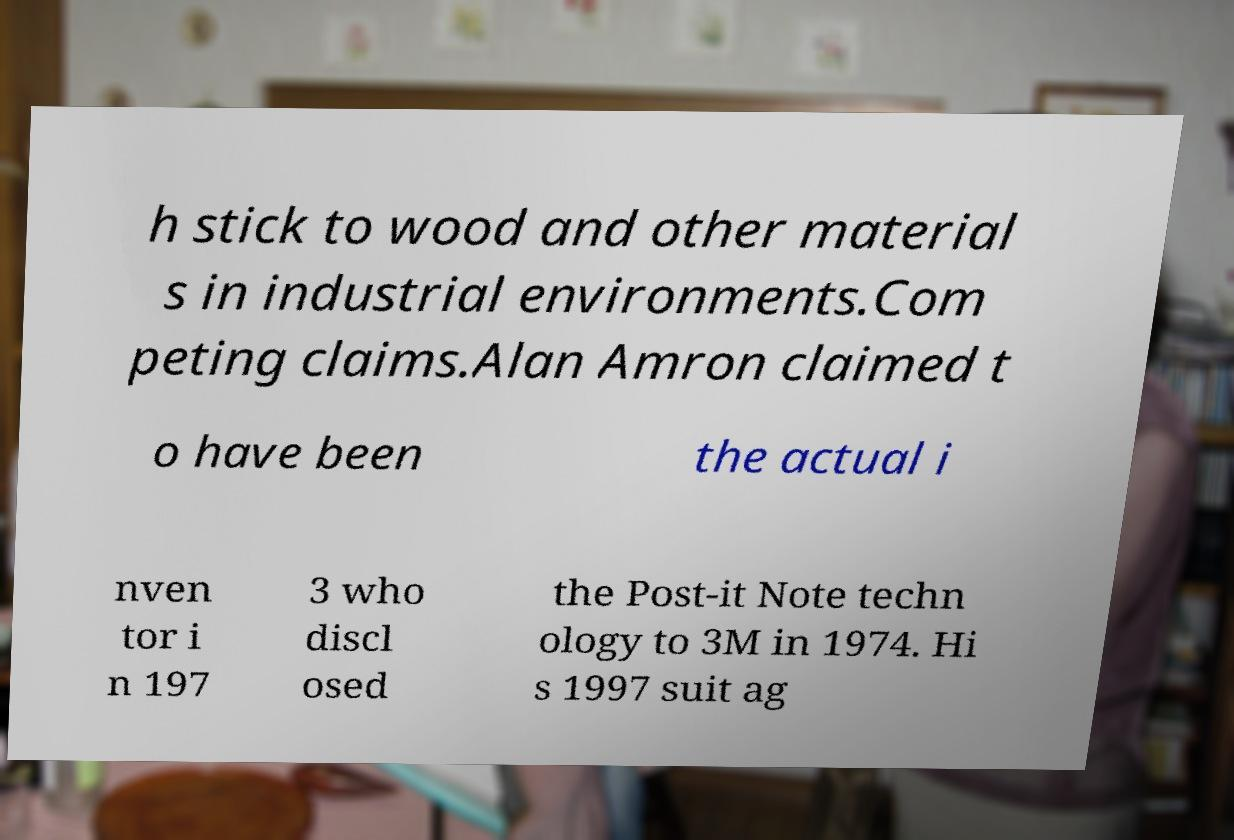Can you read and provide the text displayed in the image?This photo seems to have some interesting text. Can you extract and type it out for me? h stick to wood and other material s in industrial environments.Com peting claims.Alan Amron claimed t o have been the actual i nven tor i n 197 3 who discl osed the Post-it Note techn ology to 3M in 1974. Hi s 1997 suit ag 